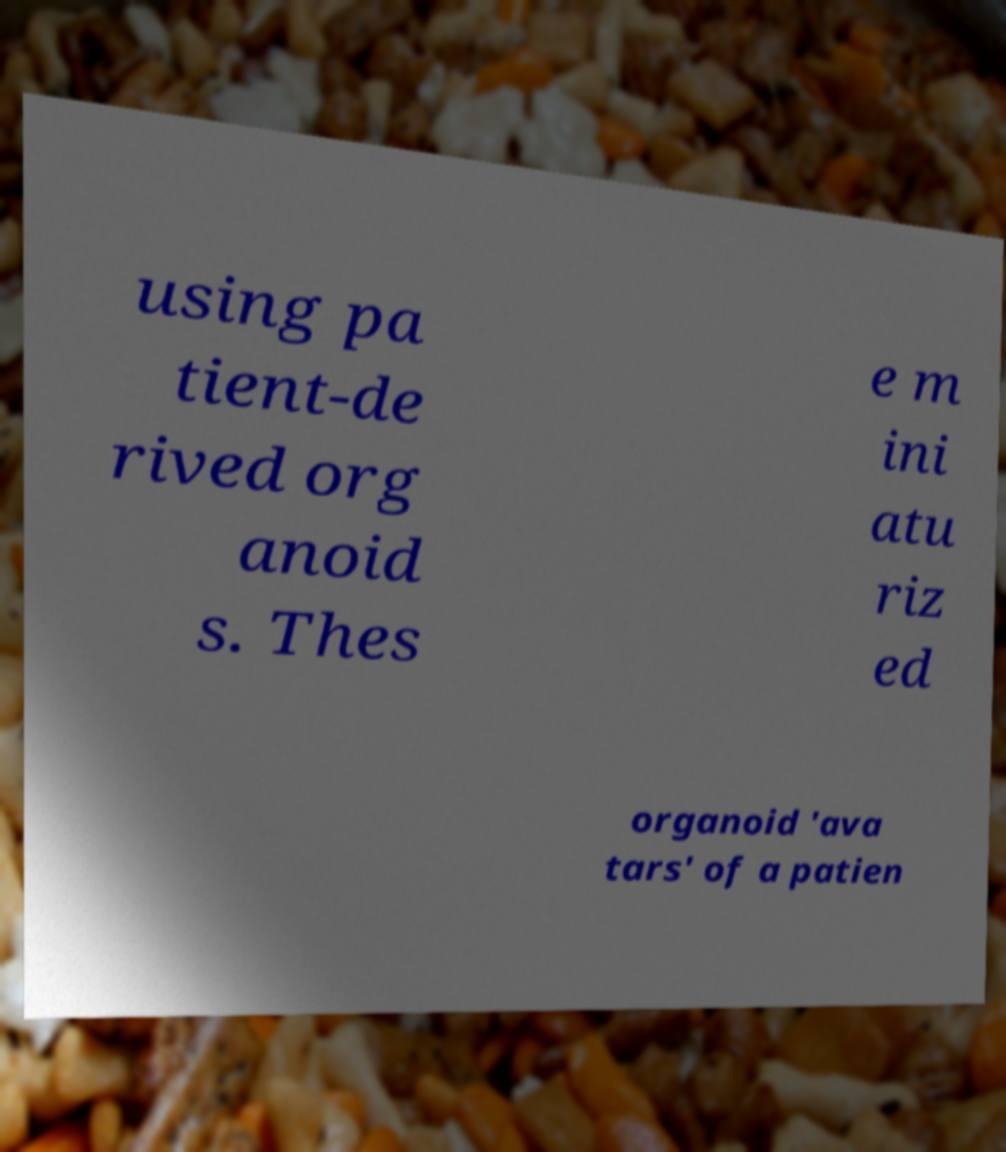Please identify and transcribe the text found in this image. using pa tient-de rived org anoid s. Thes e m ini atu riz ed organoid 'ava tars' of a patien 